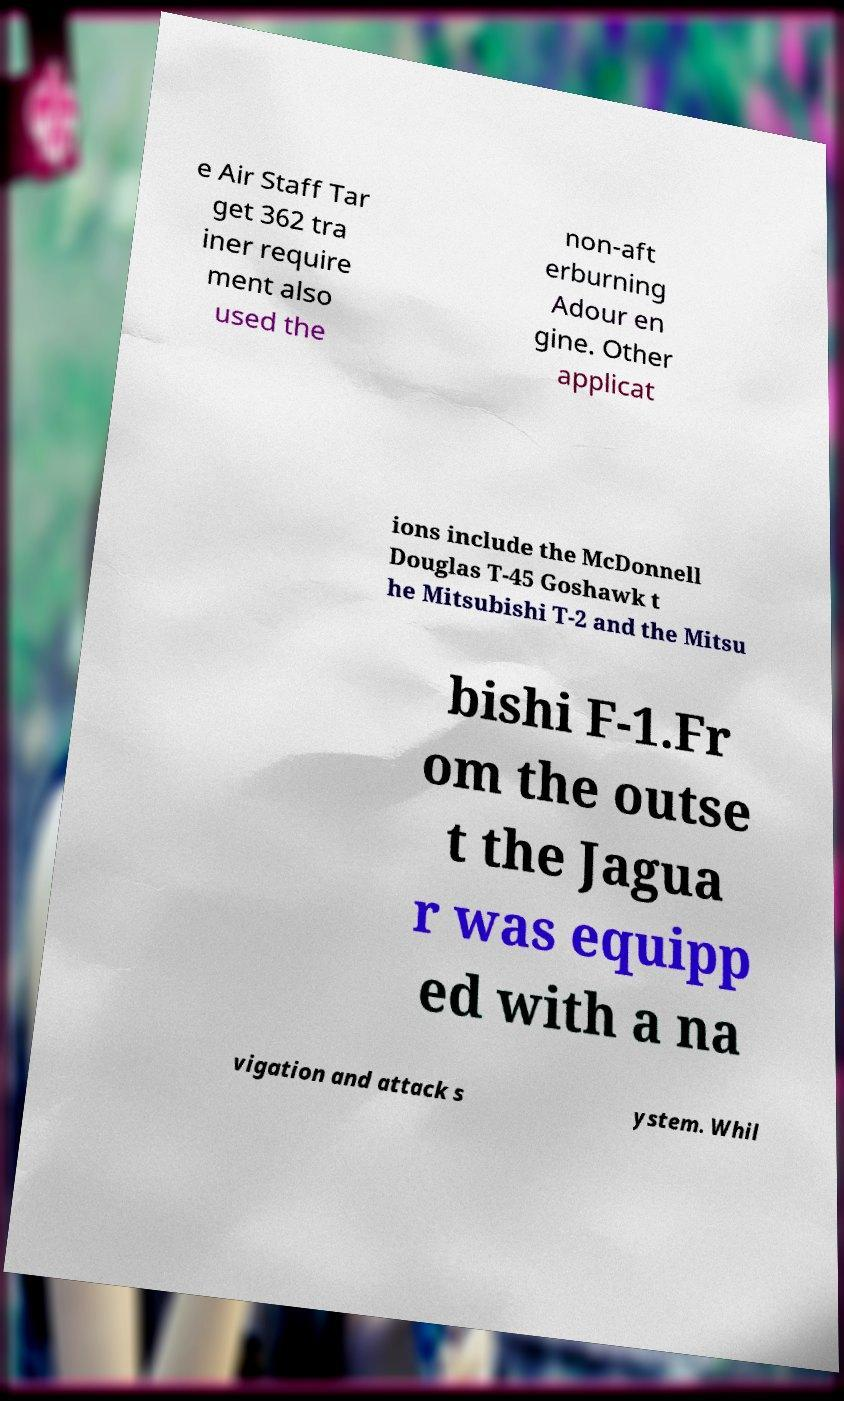For documentation purposes, I need the text within this image transcribed. Could you provide that? e Air Staff Tar get 362 tra iner require ment also used the non-aft erburning Adour en gine. Other applicat ions include the McDonnell Douglas T-45 Goshawk t he Mitsubishi T-2 and the Mitsu bishi F-1.Fr om the outse t the Jagua r was equipp ed with a na vigation and attack s ystem. Whil 